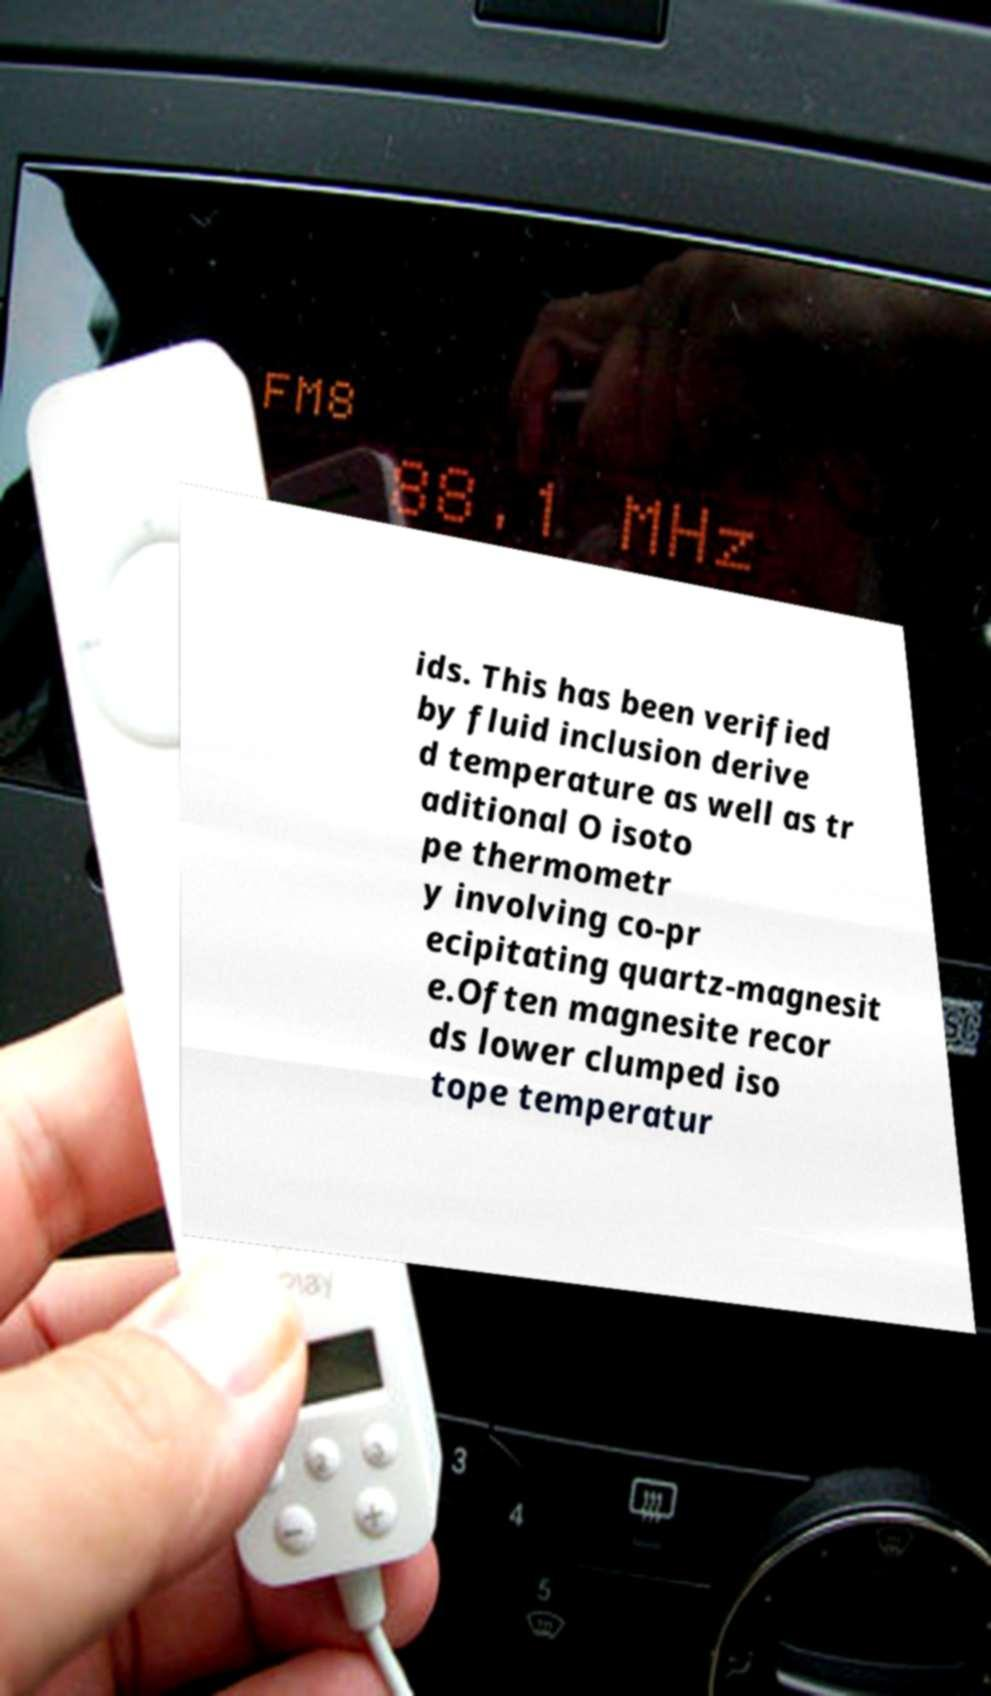What messages or text are displayed in this image? I need them in a readable, typed format. ids. This has been verified by fluid inclusion derive d temperature as well as tr aditional O isoto pe thermometr y involving co-pr ecipitating quartz-magnesit e.Often magnesite recor ds lower clumped iso tope temperatur 